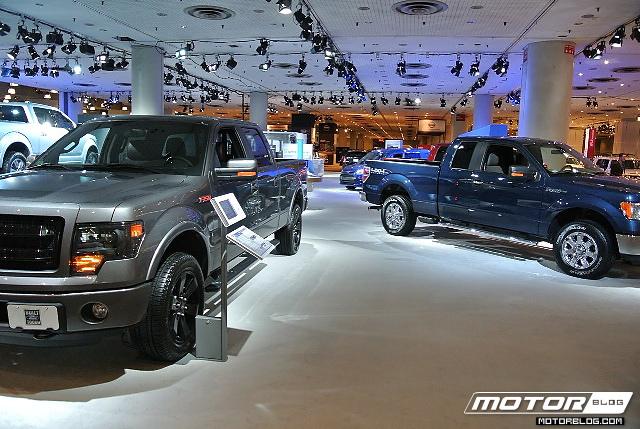What is the name of the blog?
Short answer required. Motor. How many lights are on the ceiling?
Quick response, please. 50. Do people own these trucks?
Concise answer only. No. 